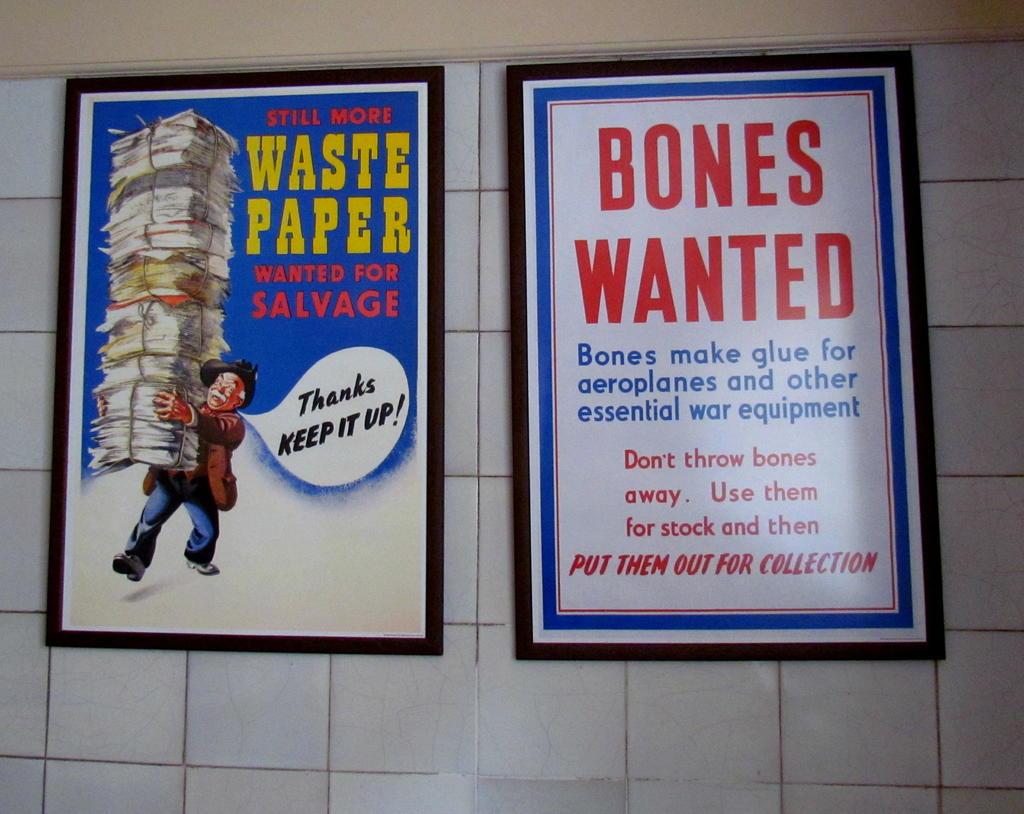What is wanted by the far right poster?
Offer a terse response. Bones. What is the boy saying?
Offer a very short reply. Thanks keep it up!. 